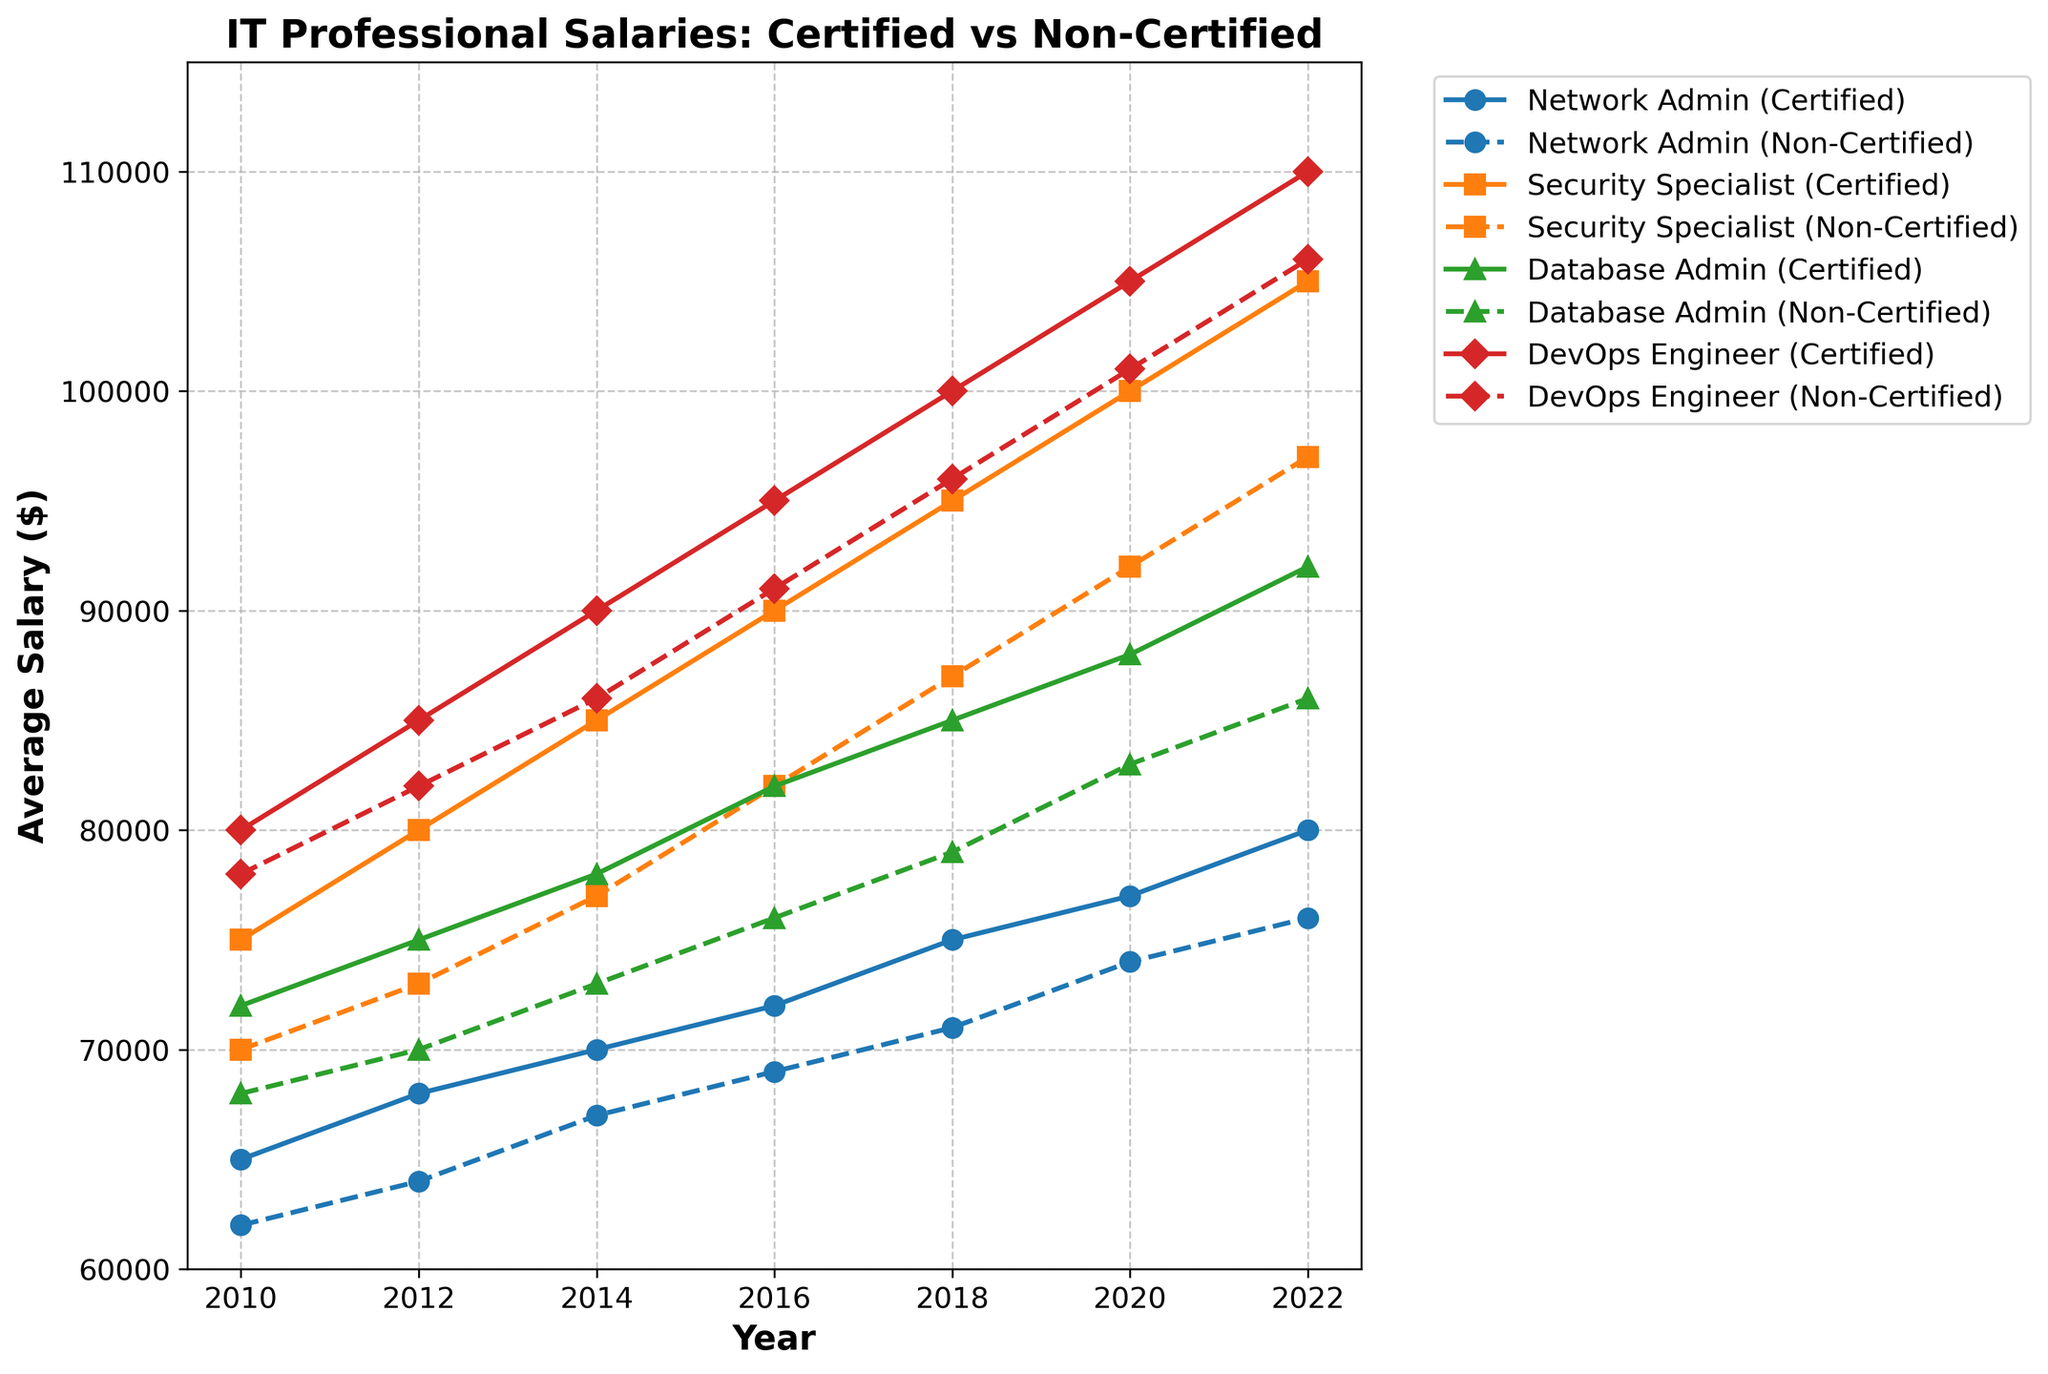Which specialization has the highest certified salary in 2022? Look at the endpoint of each certified salary line in 2022. The highest point belongs to the "DevOps Engineer (Certified)" line.
Answer: DevOps Engineer What is the difference between the salaries of certified and non-certified Security Specialists in 2018? Find the values for certified and non-certified Security Specialists in 2018. Subtract the non-certified value (87000) from the certified value (95000): 95000 - 87000 = 8000
Answer: 8000 Which specialization shows the largest increase in non-certified salary from 2010 to 2022? Calculate the increase for each specialization by subtracting the 2010 value from the 2022 value. The increases are: Network Admin: (76000-62000), Security Specialist: (97000-70000), Database Admin: (86000-68000), DevOps Engineer: (106000-78000). Compare these values: Network Admin: 14000, Security Specialist: 27000, Database Admin: 18000, DevOps Engineer: 28000. The largest is for DevOps Engineer.
Answer: DevOps Engineer In which year do certified Network Admins surpass $70,000 in average salary? Follow the "Network Admin (Certified)" line and find the first year it reaches above $70,000. It happens in 2014.
Answer: 2014 How much more did certified Database Admins earn compared to non-certified Database Admins in 2020? Find the values for certified and non-certified Database Admins in 2020 and subtract the non-certified value (83000) from the certified value (88000): 88000 - 83000 = 5000
Answer: 5000 What is the average salary for certified professionals across all specializations in 2020? To find the average, sum the certified salaries in 2020: (77000 + 100000 + 88000 + 105000) = 370000. Divide this by 4 (number of specializations) to get the average: 370000 / 4 = 92500
Answer: 92500 Between 2010 and 2020, which specialization (certified or non-certified) had the smallest salary growth? Calculate the growth for each line by subtracting the 2010 value from the 2020 value. Certified: (Network Admin: (77000-65000), Security Specialist: (100000-75000), Database Admin: (88000-72000), DevOps Engineer: (105000-80000)). Non-Certified: (Network Admin: (74000-62000), Security Specialist: (92000-70000), Database Admin: (83000-68000), DevOps Engineer: (101000-78000)). Compare these values: Network Admin (Certified: 12000, Non-Certified: 12000), Security Specialist (Certified: 25000, Non-Certified: 22000), Database Admin (Certified: 16000, Non-Certified: 15000), DevOps Engineer (Certified: 25000, Non-Certified: 23000). The smallest growth is for both Certified and Non-Certified Network Admin.
Answer: Network Admin How do the certified and non-certified salaries for Security Specialists in 2016 compare? Look at the values for Security Specialists in 2016 and compare them: Certified (90000) vs Non-Certified (82000). Certified is greater.
Answer: Certified is higher Which role had the highest increase in certified salary between 2014 and 2018? Calculate the increase in certified salary for each specialization between 2014 and 2018: Network Admin (75000-70000), Security Specialist (95000-85000), Database Admin (85000-78000), DevOps Engineer (100000-90000). Compare these values: Network Admin: 5000, Security Specialist: 10000, Database Admin: 7000, DevOps Engineer: 10000. The highest increase is for Security Specialist and DevOps Engineer.
Answer: Security Specialist and DevOps Engineer In what year did the average salary for certified Database Admins first cross $80,000? Follow the certified Database Admin line and find the first year it crosses $80,000. It happened in 2016.
Answer: 2016 